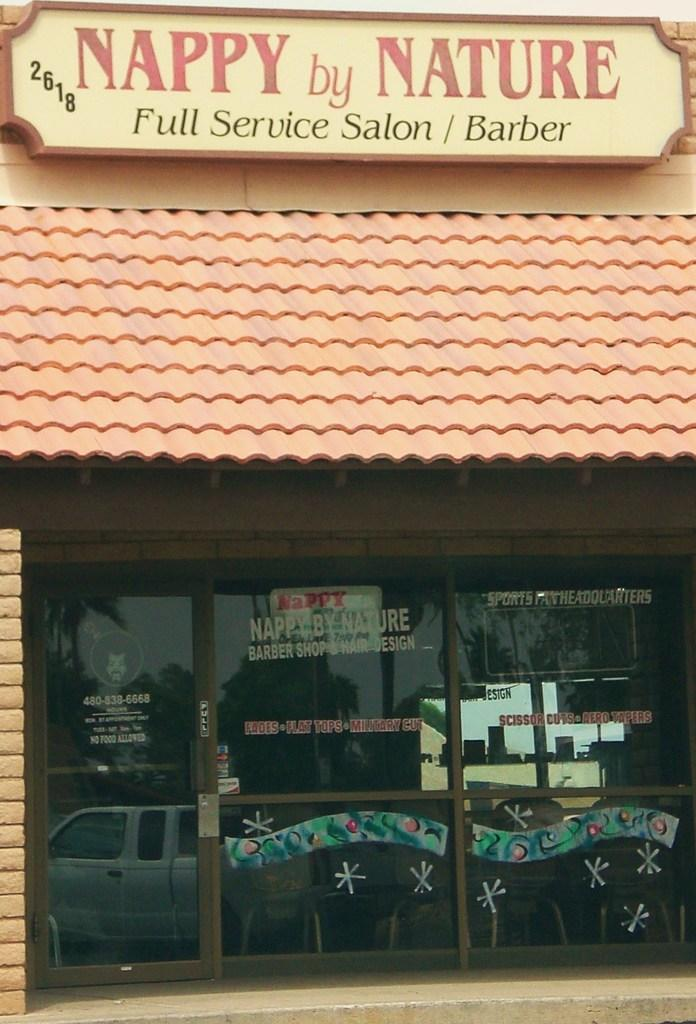What type of structure is present in the image? There is a building in the image. What is located at the top of the building? There is a board at the top of the building. What can be seen on the board? There is text on the board. What feature of the building allows access? There is a glass door in the image. What can be seen through the glass door? A vehicle and trees are visible through the glass door. What type of sound can be heard coming from the tray in the image? There is no tray present in the image, so no sound can be heard from it. 